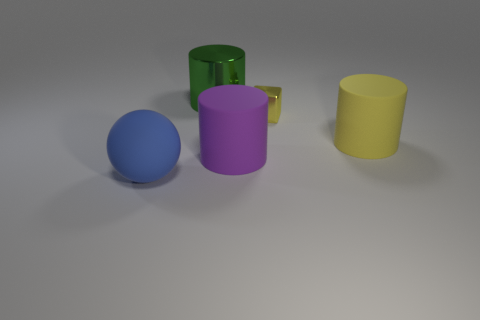How many other things are there of the same color as the block?
Offer a very short reply. 1. What material is the large yellow object?
Provide a succinct answer. Rubber. What is the big cylinder that is in front of the large green object and on the left side of the large yellow object made of?
Your response must be concise. Rubber. What number of things are either large matte things that are to the left of the large purple cylinder or large matte cylinders?
Offer a very short reply. 3. Are there any yellow rubber objects of the same size as the metallic cube?
Give a very brief answer. No. What number of large cylinders are in front of the tiny yellow metallic cube and behind the big purple cylinder?
Provide a short and direct response. 1. What number of small blocks are on the left side of the big yellow thing?
Offer a terse response. 1. Is there a purple matte object of the same shape as the big green metallic object?
Provide a succinct answer. Yes. Does the small metal object have the same shape as the thing that is behind the small shiny cube?
Give a very brief answer. No. What number of cylinders are either large metal objects or large blue matte objects?
Your answer should be very brief. 1. 